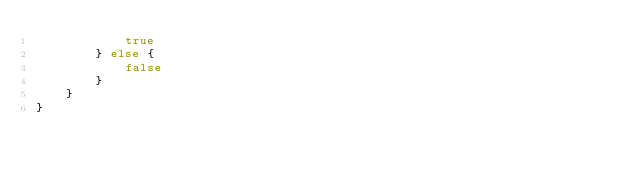<code> <loc_0><loc_0><loc_500><loc_500><_Rust_>            true
        } else {
            false
        }
    }
}
</code> 